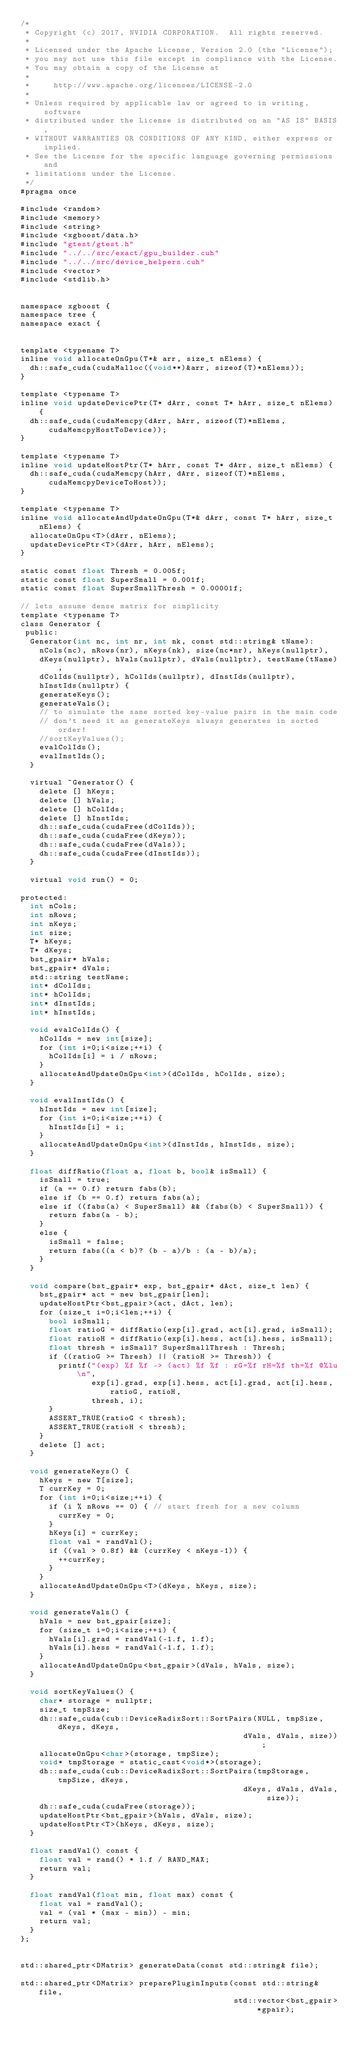Convert code to text. <code><loc_0><loc_0><loc_500><loc_500><_Cuda_>/*
 * Copyright (c) 2017, NVIDIA CORPORATION.  All rights reserved.
 *
 * Licensed under the Apache License, Version 2.0 (the "License");
 * you may not use this file except in compliance with the License.
 * You may obtain a copy of the License at
 *
 *     http://www.apache.org/licenses/LICENSE-2.0
 *
 * Unless required by applicable law or agreed to in writing, software
 * distributed under the License is distributed on an "AS IS" BASIS,
 * WITHOUT WARRANTIES OR CONDITIONS OF ANY KIND, either express or implied.
 * See the License for the specific language governing permissions and
 * limitations under the License.
 */
#pragma once

#include <random>
#include <memory>
#include <string>
#include <xgboost/data.h>
#include "gtest/gtest.h"
#include "../../src/exact/gpu_builder.cuh"
#include "../../src/device_helpers.cuh"
#include <vector>
#include <stdlib.h>


namespace xgboost {
namespace tree {
namespace exact {


template <typename T>
inline void allocateOnGpu(T*& arr, size_t nElems) {
  dh::safe_cuda(cudaMalloc((void**)&arr, sizeof(T)*nElems));
}

template <typename T>
inline void updateDevicePtr(T* dArr, const T* hArr, size_t nElems) {
  dh::safe_cuda(cudaMemcpy(dArr, hArr, sizeof(T)*nElems, cudaMemcpyHostToDevice));
}

template <typename T>
inline void updateHostPtr(T* hArr, const T* dArr, size_t nElems) {
  dh::safe_cuda(cudaMemcpy(hArr, dArr, sizeof(T)*nElems, cudaMemcpyDeviceToHost));
}

template <typename T>
inline void allocateAndUpdateOnGpu(T*& dArr, const T* hArr, size_t nElems) {
  allocateOnGpu<T>(dArr, nElems);
  updateDevicePtr<T>(dArr, hArr, nElems);
}

static const float Thresh = 0.005f;
static const float SuperSmall = 0.001f;
static const float SuperSmallThresh = 0.00001f;

// lets assume dense matrix for simplicity
template <typename T>
class Generator {
 public:
  Generator(int nc, int nr, int nk, const std::string& tName):
    nCols(nc), nRows(nr), nKeys(nk), size(nc*nr), hKeys(nullptr),
    dKeys(nullptr), hVals(nullptr), dVals(nullptr), testName(tName),
    dColIds(nullptr), hColIds(nullptr), dInstIds(nullptr),
    hInstIds(nullptr) {
    generateKeys();
    generateVals();
    // to simulate the same sorted key-value pairs in the main code
    // don't need it as generateKeys always generates in sorted order!
    //sortKeyValues();
    evalColIds();
    evalInstIds();
  }

  virtual ~Generator() {
    delete [] hKeys;
    delete [] hVals;
    delete [] hColIds;
    delete [] hInstIds;
    dh::safe_cuda(cudaFree(dColIds));
    dh::safe_cuda(cudaFree(dKeys));
    dh::safe_cuda(cudaFree(dVals));
    dh::safe_cuda(cudaFree(dInstIds));
  }

  virtual void run() = 0;

protected:
  int nCols;
  int nRows;
  int nKeys;
  int size;
  T* hKeys;
  T* dKeys;
  bst_gpair* hVals;
  bst_gpair* dVals;
  std::string testName;
  int* dColIds;
  int* hColIds;
  int* dInstIds;
  int* hInstIds;

  void evalColIds() {
    hColIds = new int[size];
    for (int i=0;i<size;++i) {
      hColIds[i] = i / nRows;
    }
    allocateAndUpdateOnGpu<int>(dColIds, hColIds, size);
  }

  void evalInstIds() {
    hInstIds = new int[size];
    for (int i=0;i<size;++i) {
      hInstIds[i] = i;
    }
    allocateAndUpdateOnGpu<int>(dInstIds, hInstIds, size);
  }

  float diffRatio(float a, float b, bool& isSmall) {
    isSmall = true;
    if (a == 0.f) return fabs(b);
    else if (b == 0.f) return fabs(a);
    else if ((fabs(a) < SuperSmall) && (fabs(b) < SuperSmall)) {
      return fabs(a - b);
    }
    else {
      isSmall = false;
      return fabs((a < b)? (b - a)/b : (a - b)/a);
    }
  }

  void compare(bst_gpair* exp, bst_gpair* dAct, size_t len) {
    bst_gpair* act = new bst_gpair[len];
    updateHostPtr<bst_gpair>(act, dAct, len);
    for (size_t i=0;i<len;++i) {
      bool isSmall;
      float ratioG = diffRatio(exp[i].grad, act[i].grad, isSmall);
      float ratioH = diffRatio(exp[i].hess, act[i].hess, isSmall);
      float thresh = isSmall? SuperSmallThresh : Thresh;
      if ((ratioG >= Thresh) || (ratioH >= Thresh)) {
        printf("(exp) %f %f -> (act) %f %f : rG=%f rH=%f th=%f @%lu\n",
               exp[i].grad, exp[i].hess, act[i].grad, act[i].hess, ratioG, ratioH,
               thresh, i);
      }
      ASSERT_TRUE(ratioG < thresh);
      ASSERT_TRUE(ratioH < thresh);
    }
    delete [] act;
  }

  void generateKeys() {
    hKeys = new T[size];
    T currKey = 0;
    for (int i=0;i<size;++i) {
      if (i % nRows == 0) { // start fresh for a new column
        currKey = 0;
      }
      hKeys[i] = currKey;
      float val = randVal();
      if ((val > 0.8f) && (currKey < nKeys-1)) {
        ++currKey;
      }
    }
    allocateAndUpdateOnGpu<T>(dKeys, hKeys, size);
  }

  void generateVals() {
    hVals = new bst_gpair[size];
    for (size_t i=0;i<size;++i) {
      hVals[i].grad = randVal(-1.f, 1.f);
      hVals[i].hess = randVal(-1.f, 1.f);
    }
    allocateAndUpdateOnGpu<bst_gpair>(dVals, hVals, size);
  }

  void sortKeyValues() {
    char* storage = nullptr;
    size_t tmpSize;
    dh::safe_cuda(cub::DeviceRadixSort::SortPairs(NULL, tmpSize, dKeys, dKeys,
                                               dVals, dVals, size));
    allocateOnGpu<char>(storage, tmpSize);
    void* tmpStorage = static_cast<void*>(storage);
    dh::safe_cuda(cub::DeviceRadixSort::SortPairs(tmpStorage, tmpSize, dKeys,
                                               dKeys, dVals, dVals, size));
    dh::safe_cuda(cudaFree(storage));
    updateHostPtr<bst_gpair>(hVals, dVals, size);
    updateHostPtr<T>(hKeys, dKeys, size);
  }

  float randVal() const {
    float val = rand() * 1.f / RAND_MAX;
    return val;
  }

  float randVal(float min, float max) const {
    float val = randVal();
    val = (val * (max - min)) - min;
    return val;
  }
};


std::shared_ptr<DMatrix> generateData(const std::string& file);

std::shared_ptr<DMatrix> preparePluginInputs(const std::string& file,
                                             std::vector<bst_gpair> *gpair);
</code> 